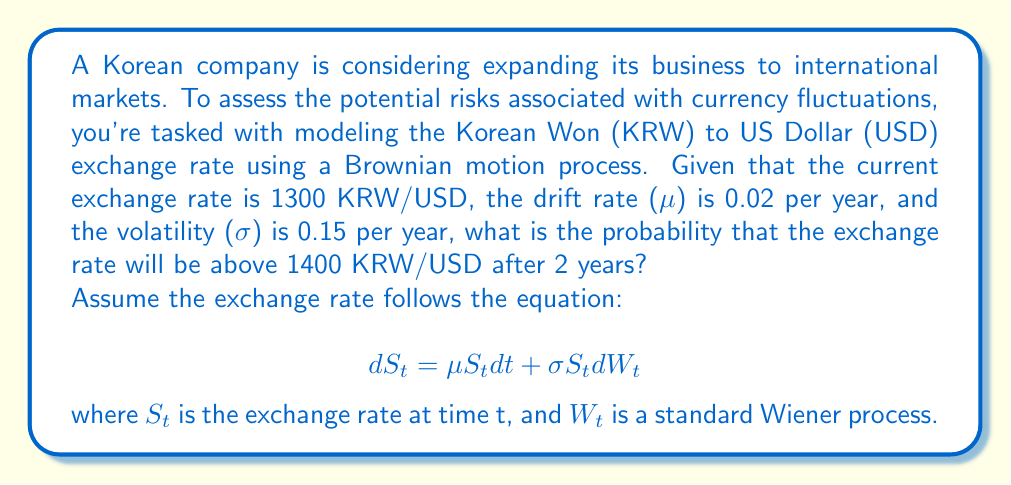Could you help me with this problem? Let's approach this step-by-step:

1) In a Geometric Brownian Motion model, the logarithm of the price ratio follows a normal distribution. The mean and variance of this distribution are given by:

   Mean: $(\mu - \frac{\sigma^2}{2})T$
   Variance: $\sigma^2 T$

   Where T is the time period.

2) Let's calculate these values:
   T = 2 years
   Mean = $(0.02 - \frac{0.15^2}{2}) * 2 = -0.00125$
   Variance = $0.15^2 * 2 = 0.045$

3) We need to find $P(S_2 > 1400)$ given $S_0 = 1300$

4) This is equivalent to finding:

   $P(\ln(\frac{S_2}{S_0}) > \ln(\frac{1400}{1300}))$

5) $\ln(\frac{1400}{1300}) = 0.0741$

6) We can standardize this to a standard normal distribution:

   $P(Z > \frac{0.0741 - (-0.00125)}{\sqrt{0.045}}) = P(Z > 0.3546)$

7) Using a standard normal table or calculator, we find:

   $P(Z > 0.3546) = 1 - 0.6385 = 0.3615$

Therefore, the probability that the exchange rate will be above 1400 KRW/USD after 2 years is approximately 0.3615 or 36.15%.
Answer: 0.3615 